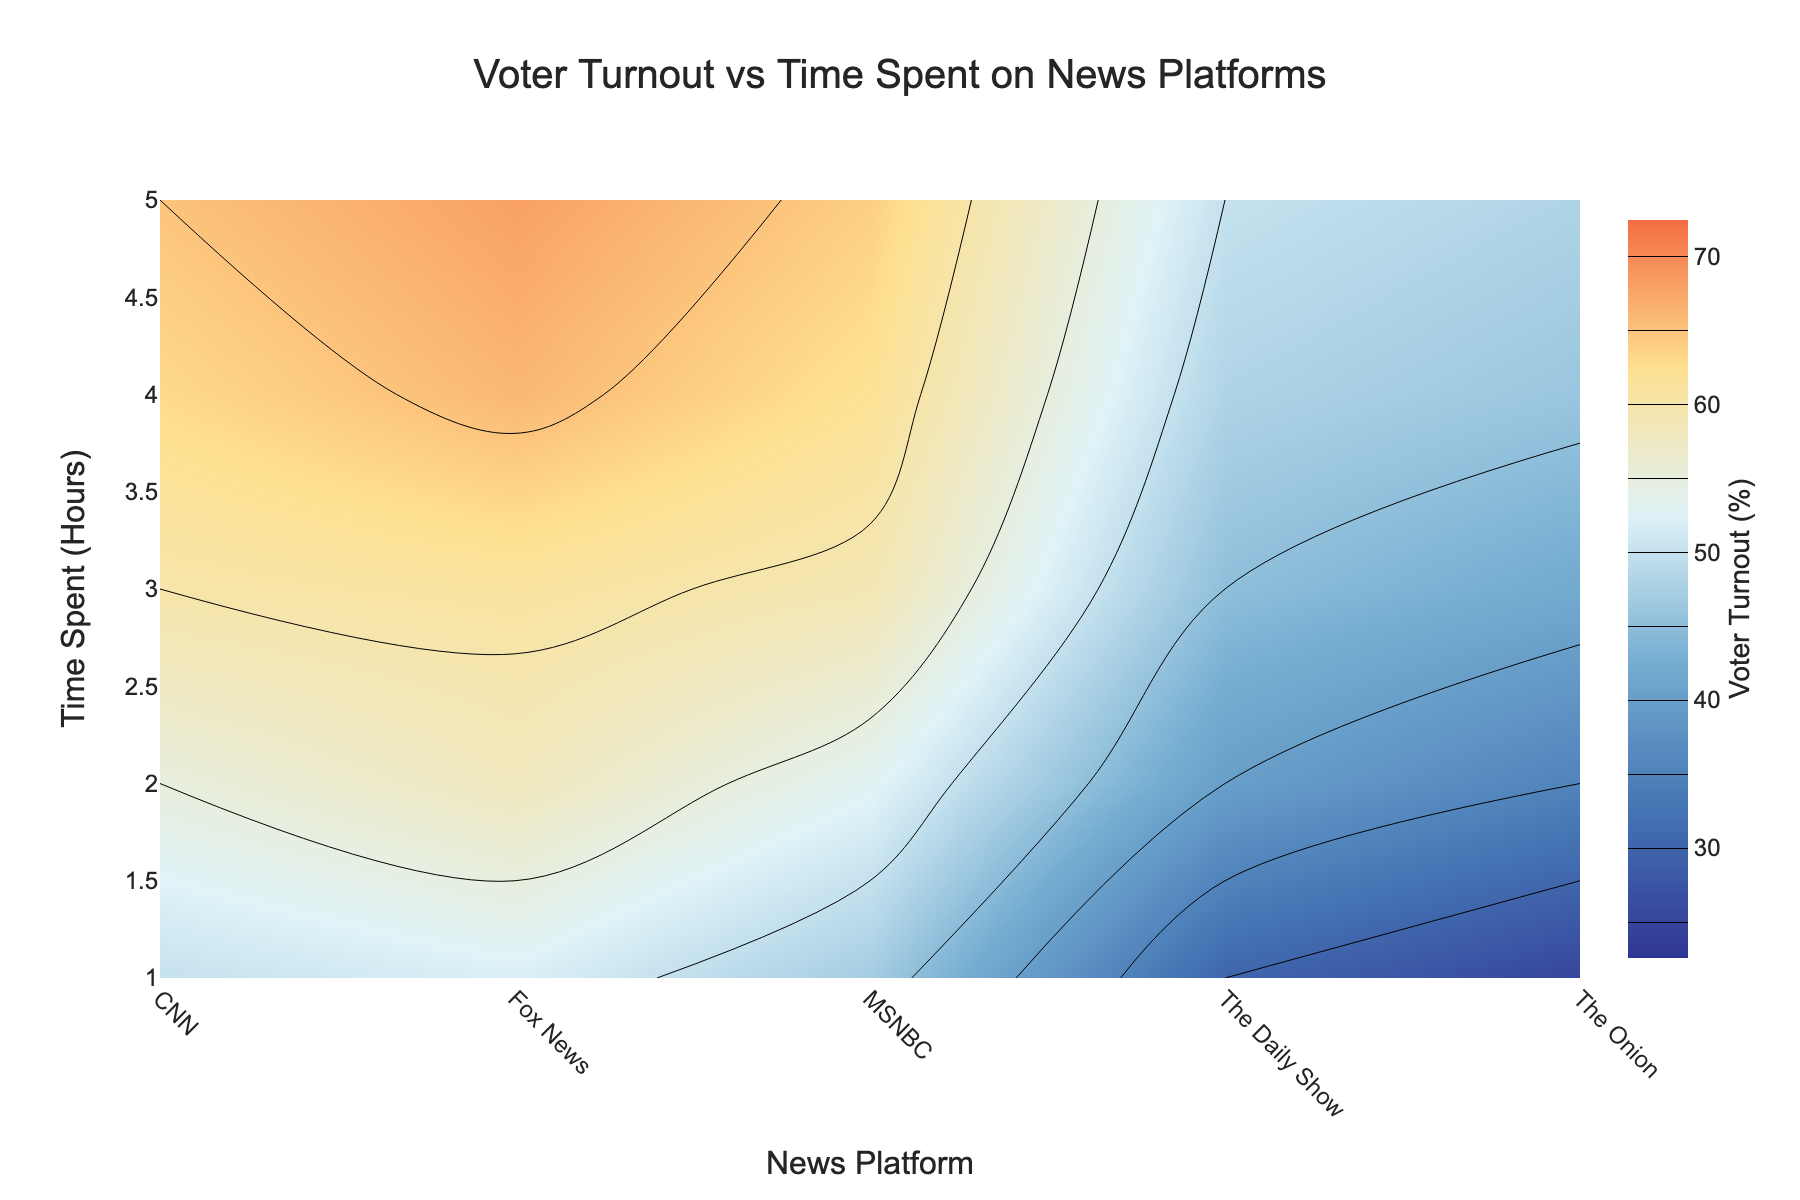what is the y-axis representing? The y-axis shows the amount of time spent on various news platforms measured in hours, as indicated by the label "Time Spent (Hours)."
Answer: Time Spent (Hours) What is the voter turnout percentage when people spend 3 hours on The Daily Show? By observing the contour levels at the point where "The Daily Show" intersects with the 3-hour mark on the graph, the voter turnout percentage lies around 45%.
Answer: 45% Which news platform shows the highest voter turnout for 5 hours of usage? Check the highest contour line values at the 5-hour mark for each news platform. Fox News shows the highest voter turnout, peaking at approximately 68%.
Answer: Fox News Is there a general trend in voter turnout with increased time spent on CNN? Observing the contour levels for CNN, we see that voter turnout percentage generally increases as more time is spent on CNN.
Answer: Increases Which news platform shows the lowest voter turnout for 2 hours of usage? Look at the 2-hour mark; The Onion shows the lowest voter turnout percentage, around 35%.
Answer: The Onion How does voter turnout for 3 hours differ between traditional news platforms and satirical news platforms? Traditional news platforms (CNN, Fox News, MSNBC) have voter turnout percentages ranging from 59% to 61%, whereas satirical news platforms (The Daily Show, The Onion) have lower turnout rates ranging from 42% to 45%.
Answer: Higher for traditional news platforms What's the average voter turnout percentage for people who spend 2 hours across all news platforms? Sum the voter turnout percentages for 2 hours of usage across all platforms and divide by the number of platforms: (55 + 58 + 53 + 40 + 35) / 5 = 48.2%.
Answer: 48.2% Which news platform sees a very high voter turnout increase between 1 and 2 hours of usage? Analyze the contour levels for a significant jump between 1 and 2 hours. The Daily Show shows a noticeable increase from 30% to 40%.
Answer: The Daily Show How does the color scale represent voter turnout percentages? The colors range from dark blue (lowest voter turnout) to bright orange (highest voter turnout), signifying various voter turnout percentages from 25% to 70%.
Answer: Dark blue to bright orange 